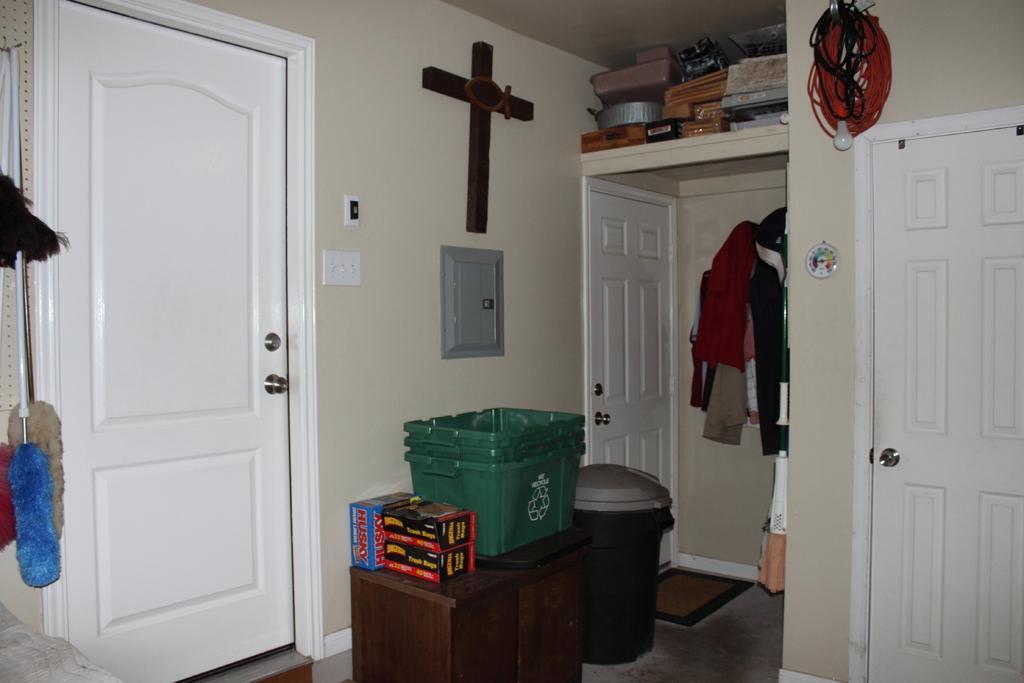Can you describe this image briefly? This image is clicked inside a room. There are doors in the middle. There is a table and on that there are some boxes. There are clothes in the middle. There are broomsticks on the left side. 